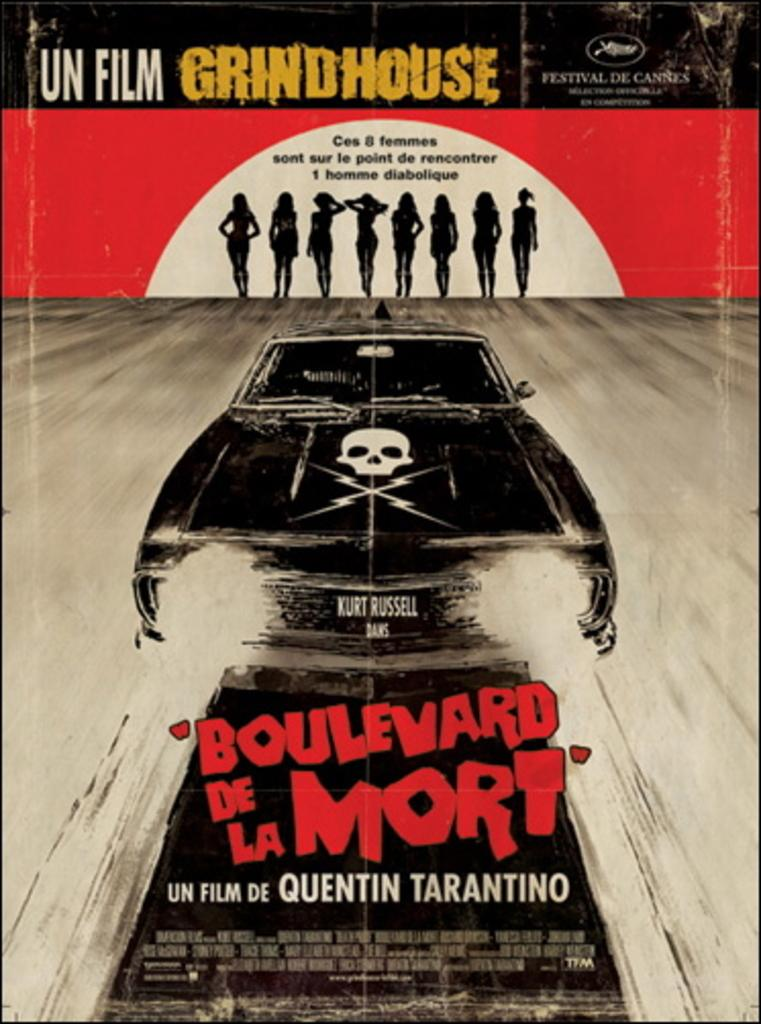Provide a one-sentence caption for the provided image. Boulevard de la Mort is a film made by Quentin Tarantino. 